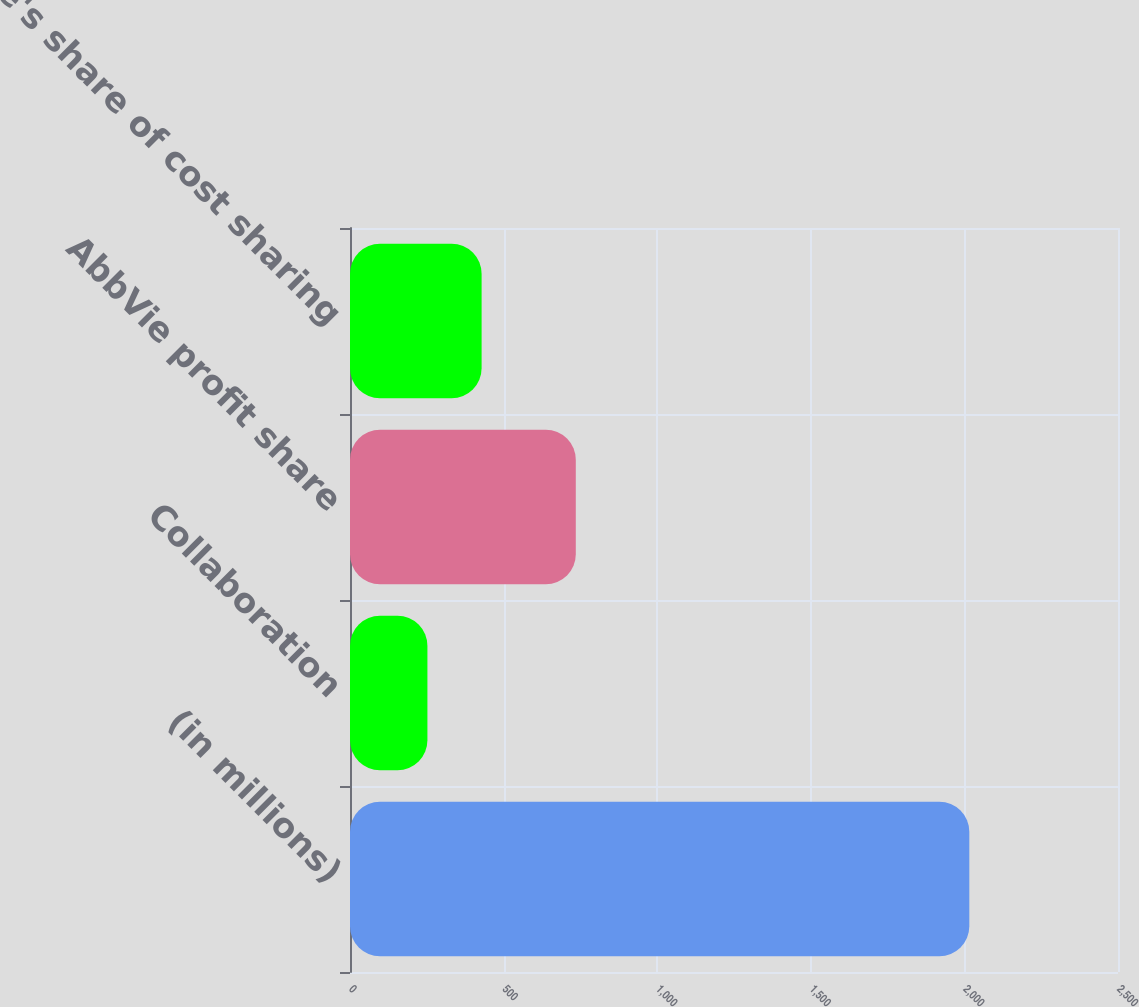Convert chart. <chart><loc_0><loc_0><loc_500><loc_500><bar_chart><fcel>(in millions)<fcel>Collaboration<fcel>AbbVie profit share<fcel>AbbVie's share of cost sharing<nl><fcel>2016<fcel>252<fcel>735<fcel>428.4<nl></chart> 